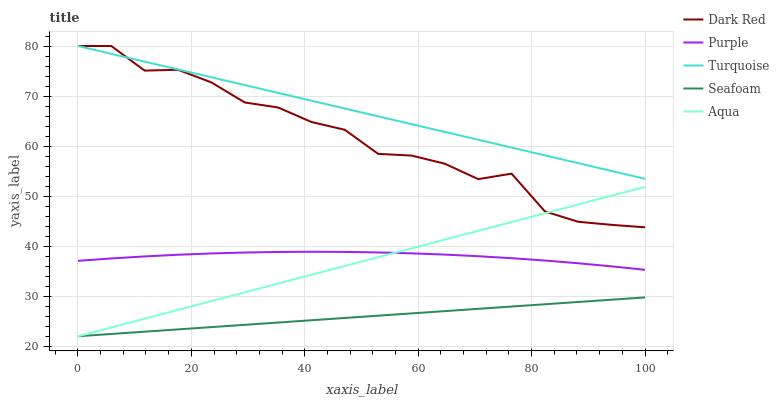Does Seafoam have the minimum area under the curve?
Answer yes or no. Yes. Does Turquoise have the maximum area under the curve?
Answer yes or no. Yes. Does Dark Red have the minimum area under the curve?
Answer yes or no. No. Does Dark Red have the maximum area under the curve?
Answer yes or no. No. Is Seafoam the smoothest?
Answer yes or no. Yes. Is Dark Red the roughest?
Answer yes or no. Yes. Is Turquoise the smoothest?
Answer yes or no. No. Is Turquoise the roughest?
Answer yes or no. No. Does Aqua have the lowest value?
Answer yes or no. Yes. Does Dark Red have the lowest value?
Answer yes or no. No. Does Turquoise have the highest value?
Answer yes or no. Yes. Does Aqua have the highest value?
Answer yes or no. No. Is Seafoam less than Dark Red?
Answer yes or no. Yes. Is Dark Red greater than Seafoam?
Answer yes or no. Yes. Does Dark Red intersect Turquoise?
Answer yes or no. Yes. Is Dark Red less than Turquoise?
Answer yes or no. No. Is Dark Red greater than Turquoise?
Answer yes or no. No. Does Seafoam intersect Dark Red?
Answer yes or no. No. 